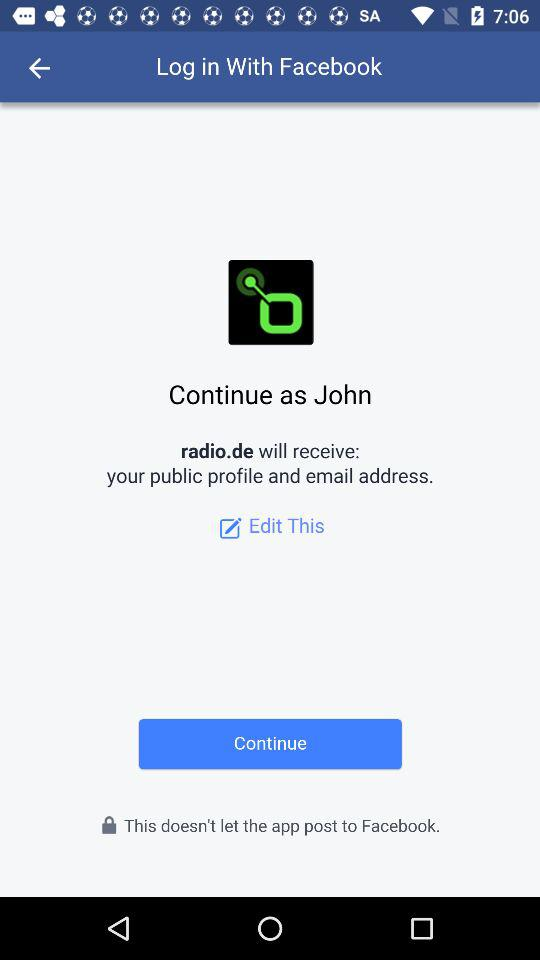What application is asking for permission? The application asking for permission is "radio.de". 